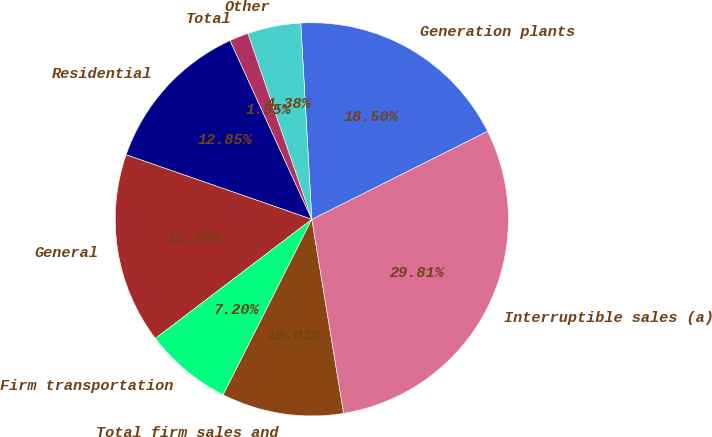Convert chart to OTSL. <chart><loc_0><loc_0><loc_500><loc_500><pie_chart><fcel>Residential<fcel>General<fcel>Firm transportation<fcel>Total firm sales and<fcel>Interruptible sales (a)<fcel>Generation plants<fcel>Other<fcel>Total<nl><fcel>12.85%<fcel>15.68%<fcel>7.2%<fcel>10.03%<fcel>29.81%<fcel>18.5%<fcel>4.38%<fcel>1.55%<nl></chart> 